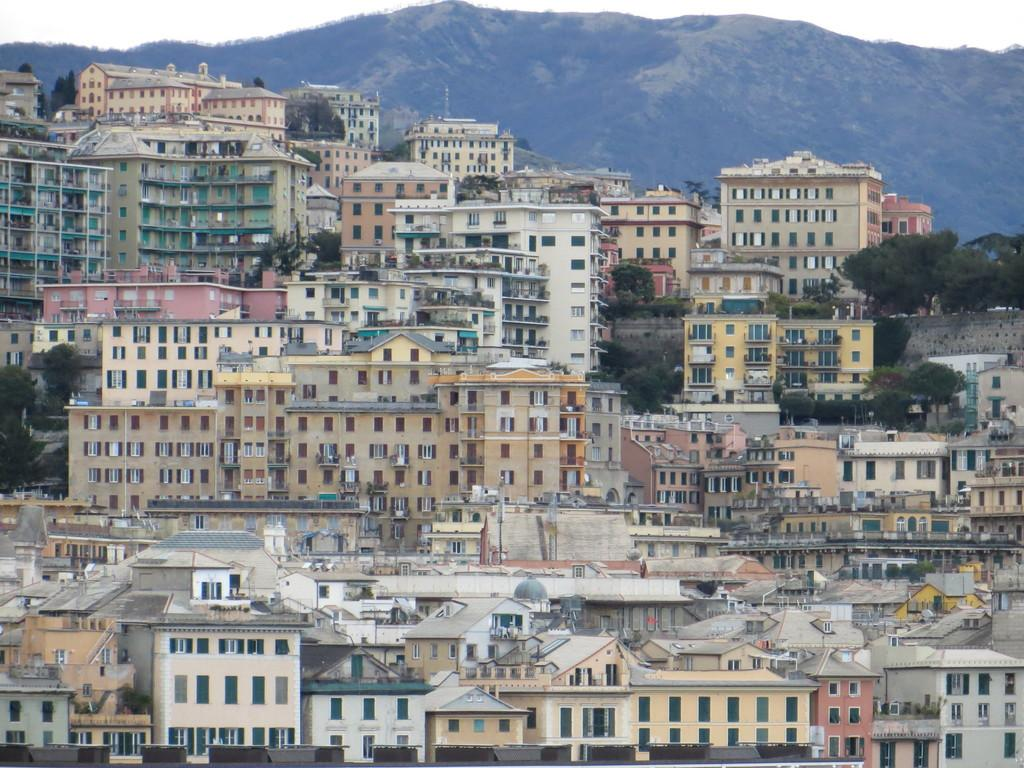What type of location is shown in the image? The image depicts a city. What structures can be seen in the city? There are buildings in the image. Are there any natural elements present in the city? Yes, there are trees in the image. What can be seen in the distance behind the city? There is a mountain visible in the background of the image. What is visible at the top of the image? The sky is visible at the top of the image. How many leaves are on the mice in the image? There are no mice or leaves present in the image. 